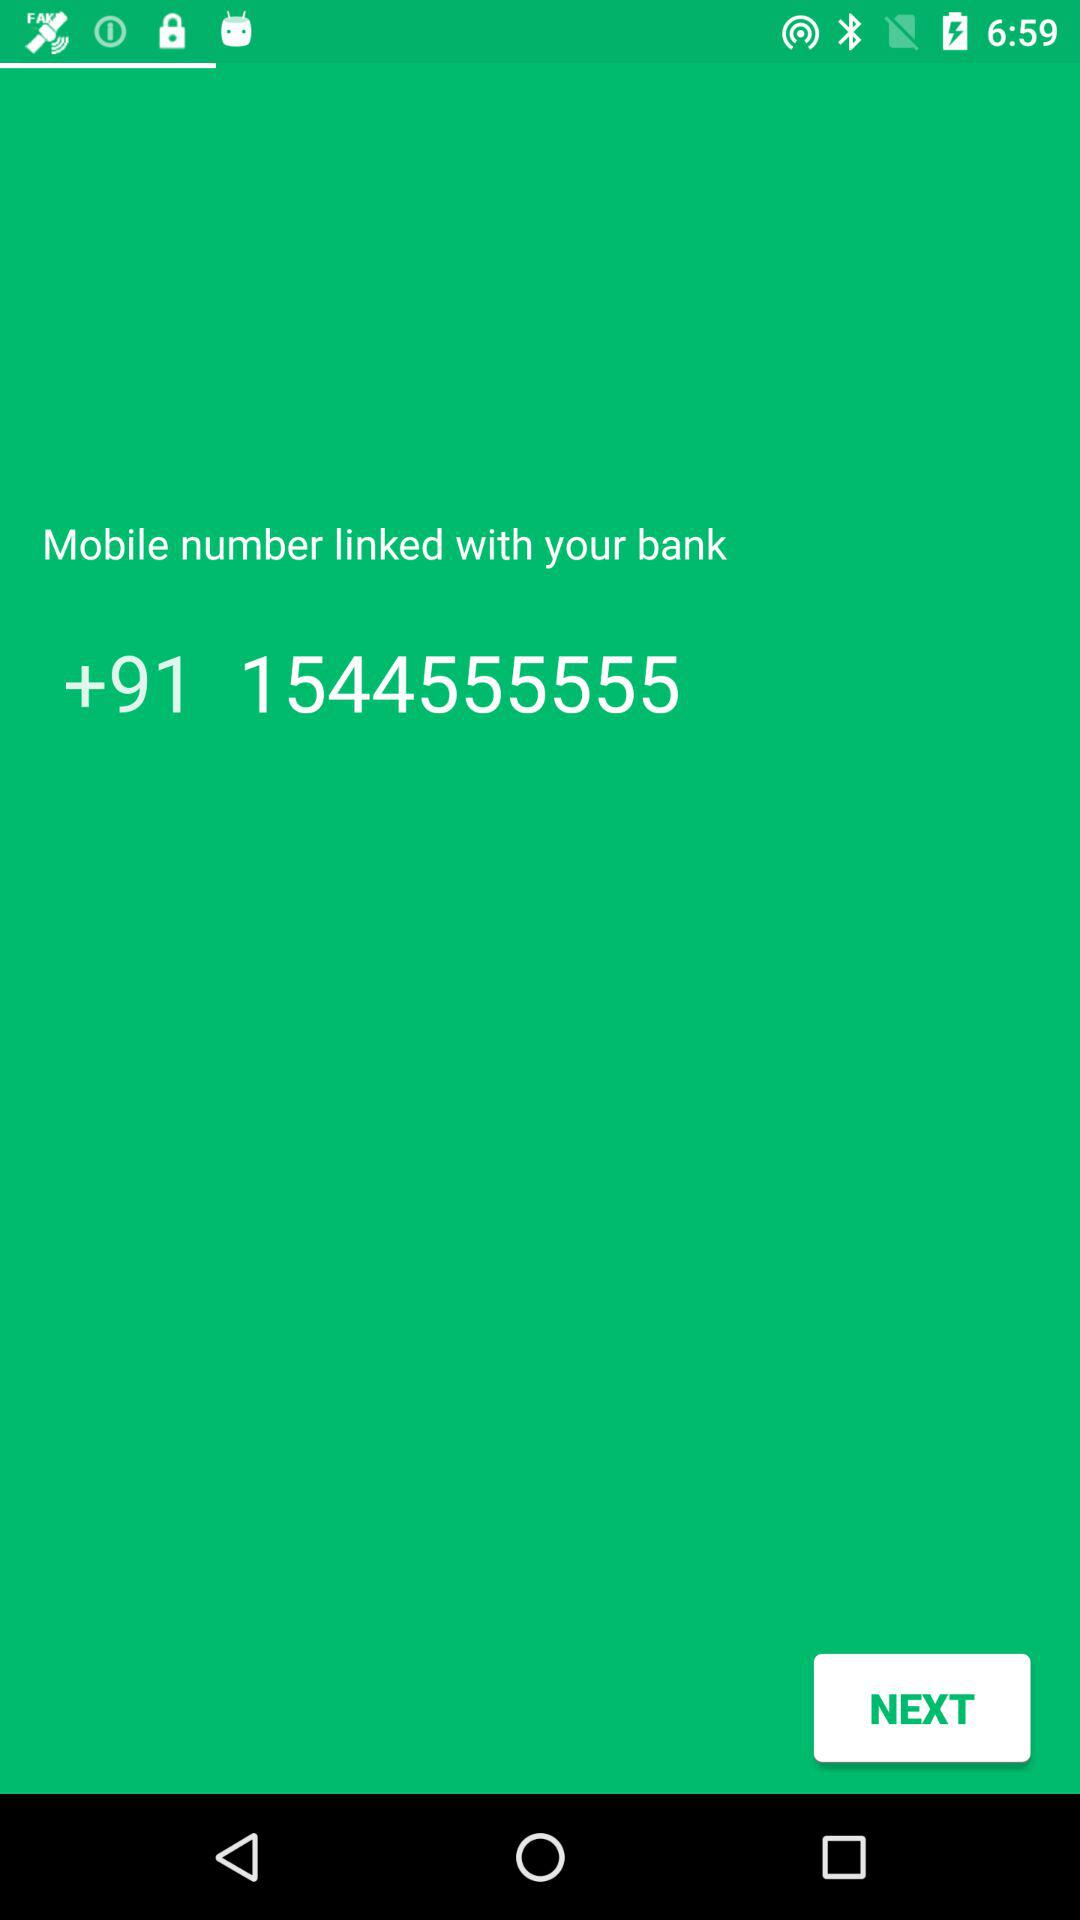What is the mobile number linked with the bank? The mobile number is +91 544555555. 